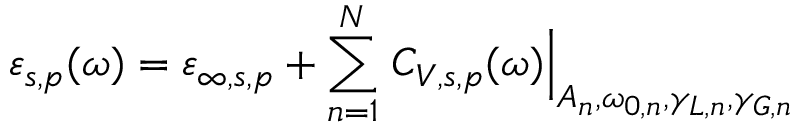<formula> <loc_0><loc_0><loc_500><loc_500>\varepsilon _ { s , p } ( \omega ) = \varepsilon _ { \infty , s , p } + \sum _ { n = 1 } ^ { N } C _ { V , s , p } ( \omega ) \right | _ { A _ { n } , \omega _ { 0 , n } , \gamma _ { L , n } , \gamma _ { G , n } }</formula> 